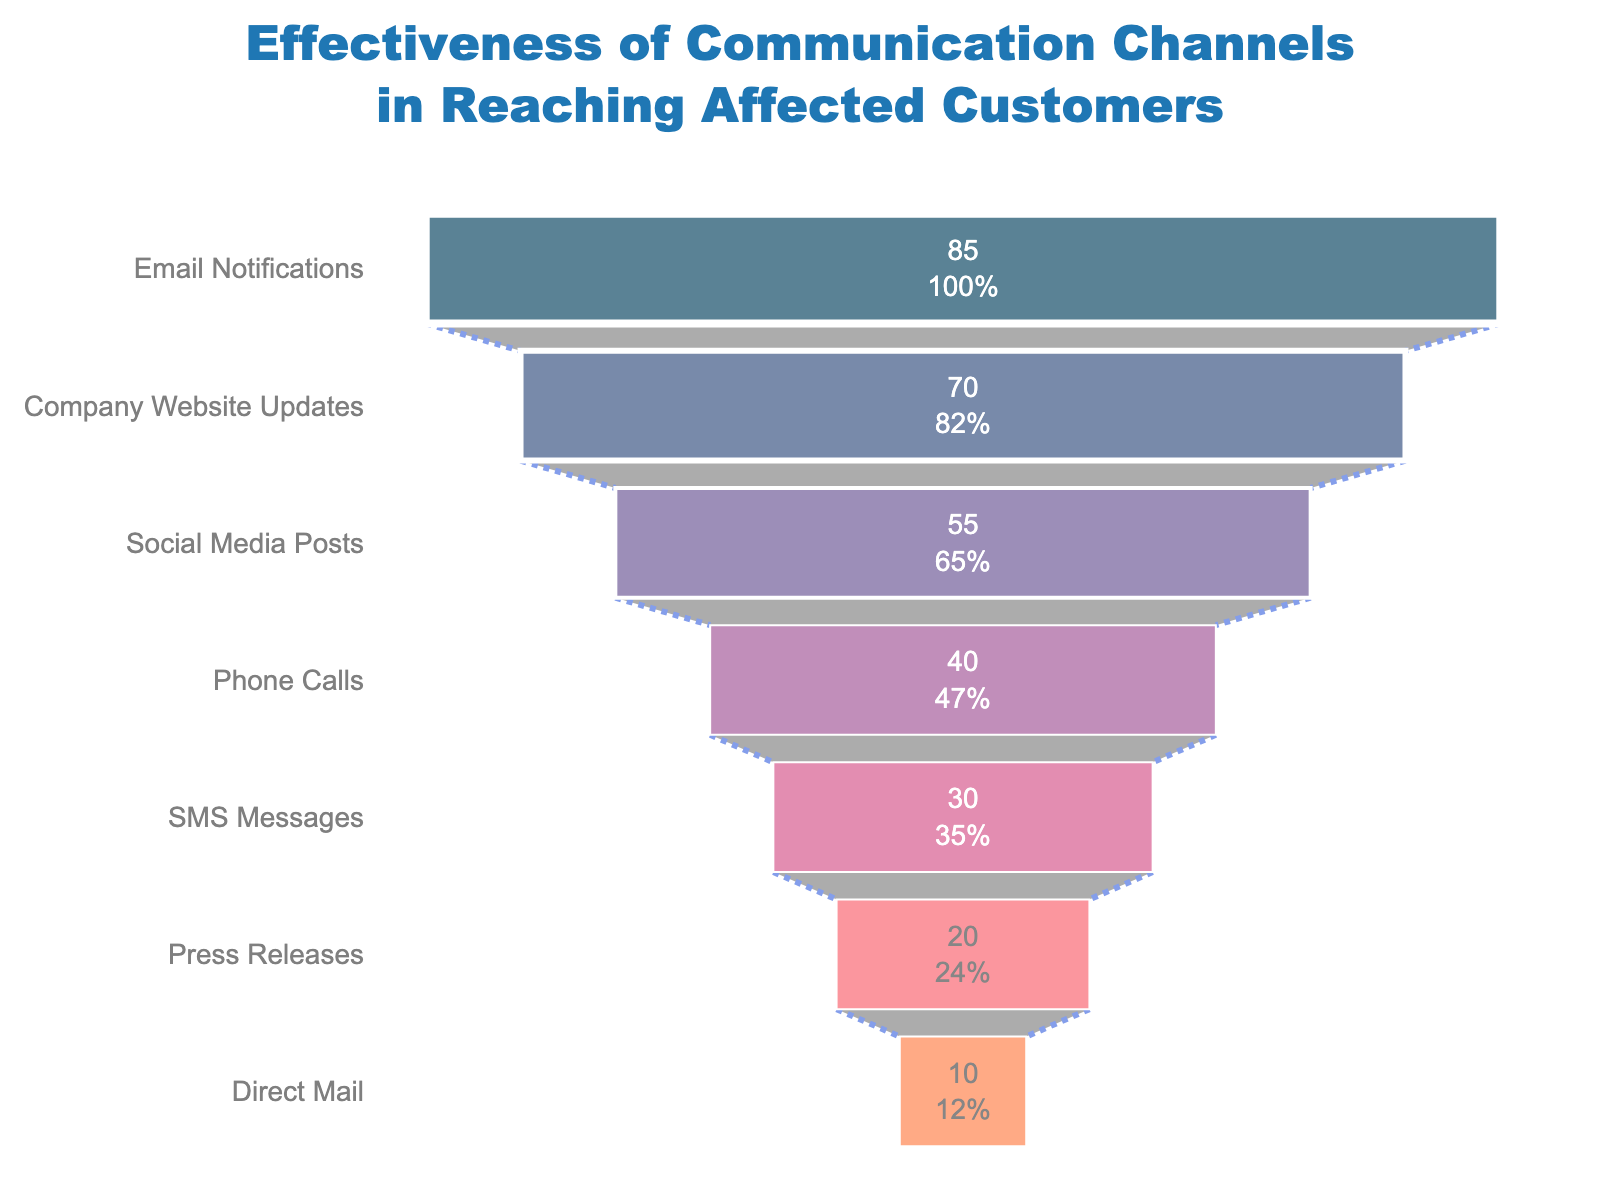How many communication channels are shown in the funnel chart? The funnel chart displays a total of 7 different communication channels. Each channel corresponds to one layer of the funnel.
Answer: 7 Which communication channel was the most effective in reaching affected customers? The topmost layer of the funnel chart shows that Email Notifications had the highest reach percentage among all the communication channels.
Answer: Email Notifications What percentage of customers were reached by Phone Calls? By looking at the specified layer for Phone Calls in the funnel chart, it shows that Phone Calls reached 40% of the affected customers.
Answer: 40% What is the difference in reach percentage between Email Notifications and SMS Messages? Subtract the reach percentage of SMS Messages (30%) from the reach percentage of Email Notifications (85%). 85% - 30% = 55%.
Answer: 55% What is the average reach percentage across all communication channels? Adding up all the reach percentages (85% + 70% + 55% + 40% + 30% + 20% + 10%) gives 310%. Dividing by 7 (the number of channels) results in an average of 310% / 7 = ~44.29%.
Answer: ~44.29% Which communication channels reached less than 50% of affected customers? Checking each layer below the 50% mark, the communication channels with less than 50% reach are Phone Calls, SMS Messages, Press Releases, and Direct Mail.
Answer: Phone Calls, SMS Messages, Press Releases, Direct Mail How much higher is the reach percentage of Company Website Updates compared to Press Releases? Subtract the reach percentage of Press Releases (20%) from that of Company Website Updates (70%). 70% - 20% = 50%.
Answer: 50% Which communication channel had the lowest reach percentage? The bottommost layer of the funnel chart indicates that Direct Mail had the lowest reach percentage among all the communication channels.
Answer: Direct Mail What is the total reach percentage of the top three communication channels? Sum the reach percentages of the top three channels: Email Notifications (85%), Company Website Updates (70%), and Social Media Posts (55%). The total is 85% + 70% + 55% = 210%.
Answer: 210% Between Social Media Posts and SMS Messages, which channel was more effective and by how much? Social Media Posts had a reach percentage of 55%, while SMS Messages had 30%. Subtract 30% from 55% to find the difference: 55% - 30% = 25%.
Answer: Social Media Posts, 25% 